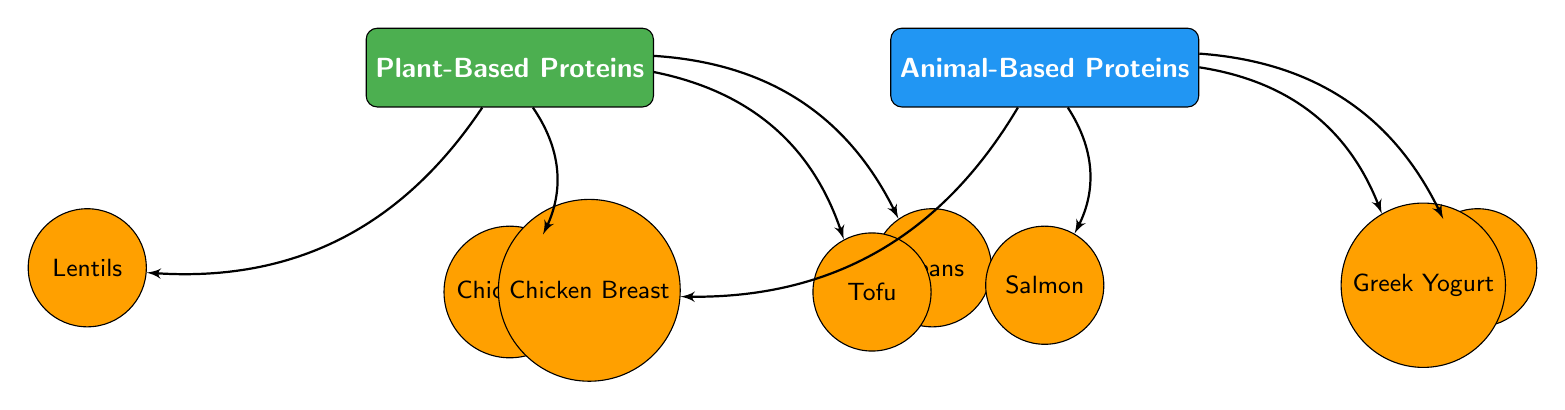What are the two categories of protein sources? The diagram shows two main categories for protein sources: Plant-Based Proteins and Animal-Based Proteins.
Answer: Plant-Based Proteins, Animal-Based Proteins How many plant-based protein sources are listed? The diagram presents four plant-based protein sources: Lentils, Chickpeas, Beans, and Tofu. Counting these nodes provides a total of four.
Answer: 4 Which source is positioned to the right of Chickpeas? According to the diagram, Tofu is directly positioned to the right of Chickpeas, indicating the relationship between these two sources.
Answer: Tofu Which animal-based protein source is located below right of Animal-Based Proteins? The source directly located below right of the Animal-Based Proteins category is Eggs. This can be identified by following the connection downwards and to the right from the animal node.
Answer: Eggs What is the relationship between Plant-Based Proteins and Tofu? The diagram shows a direct arrow pointing from the Plant-Based Proteins category to Tofu, indicating that Tofu is considered a type of Plant-Based Protein.
Answer: Tofu is a Plant-Based Protein Which protein source is closest to the Animal-Based Proteins category? Salmon is the closest protein source to the Animal-Based Proteins category as it is directly below it without any nodes in between.
Answer: Salmon How many sources are there in total in the diagram? By counting all the nodes, there are a total of eight sources: four plant-based (Lentils, Chickpeas, Beans, Tofu) and four animal-based (Chicken Breast, Salmon, Eggs, Greek Yogurt). Adding these gives a total of eight.
Answer: 8 What type of protein is Chicken Breast classified as? Chicken Breast falls under the category of Animal-Based Proteins, as indicated by its placement in the diagram.
Answer: Animal-Based Protein Which plant-based protein source is depicted below left of the Plant-Based Proteins? The source depicted below left of Plant-Based Proteins is Lentils, which can be confirmed by tracing the connection from the category downwards and to the left.
Answer: Lentils 